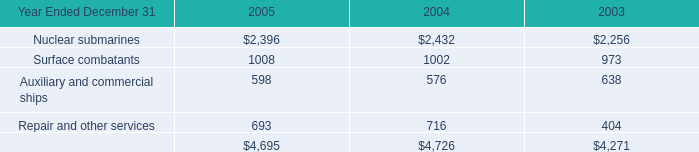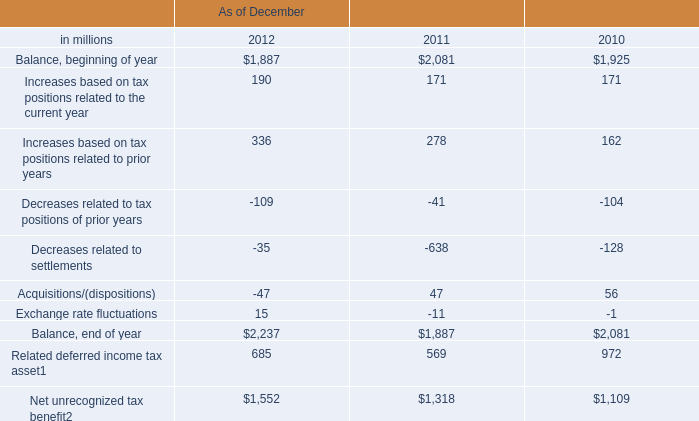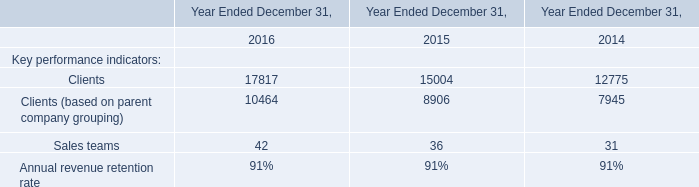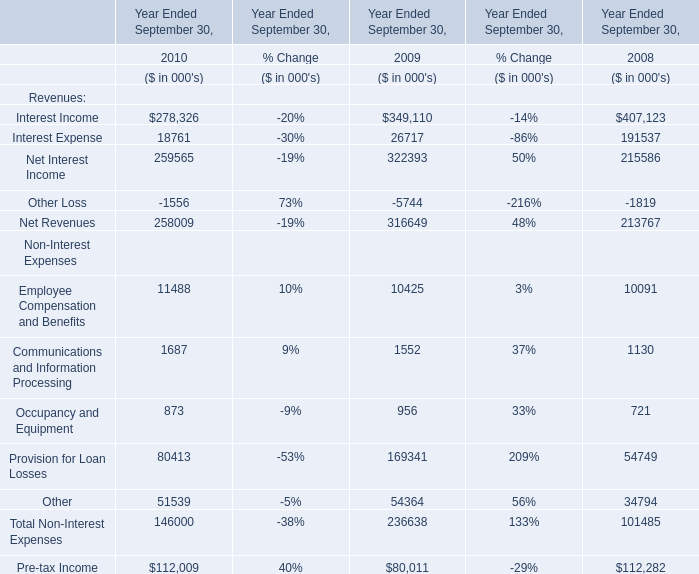What is the total amount of Balance, beginning of year of As of December 2011, and Clients of Year Ended December 31, 2016 ? 
Computations: (2081.0 + 17817.0)
Answer: 19898.0. 